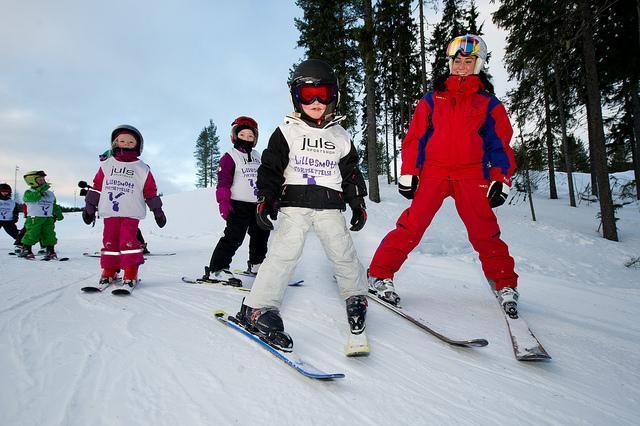How many people are in the picture?
Give a very brief answer. 6. How many people are smiling?
Give a very brief answer. 1. How many people are there?
Give a very brief answer. 5. How many ski are there?
Give a very brief answer. 2. 